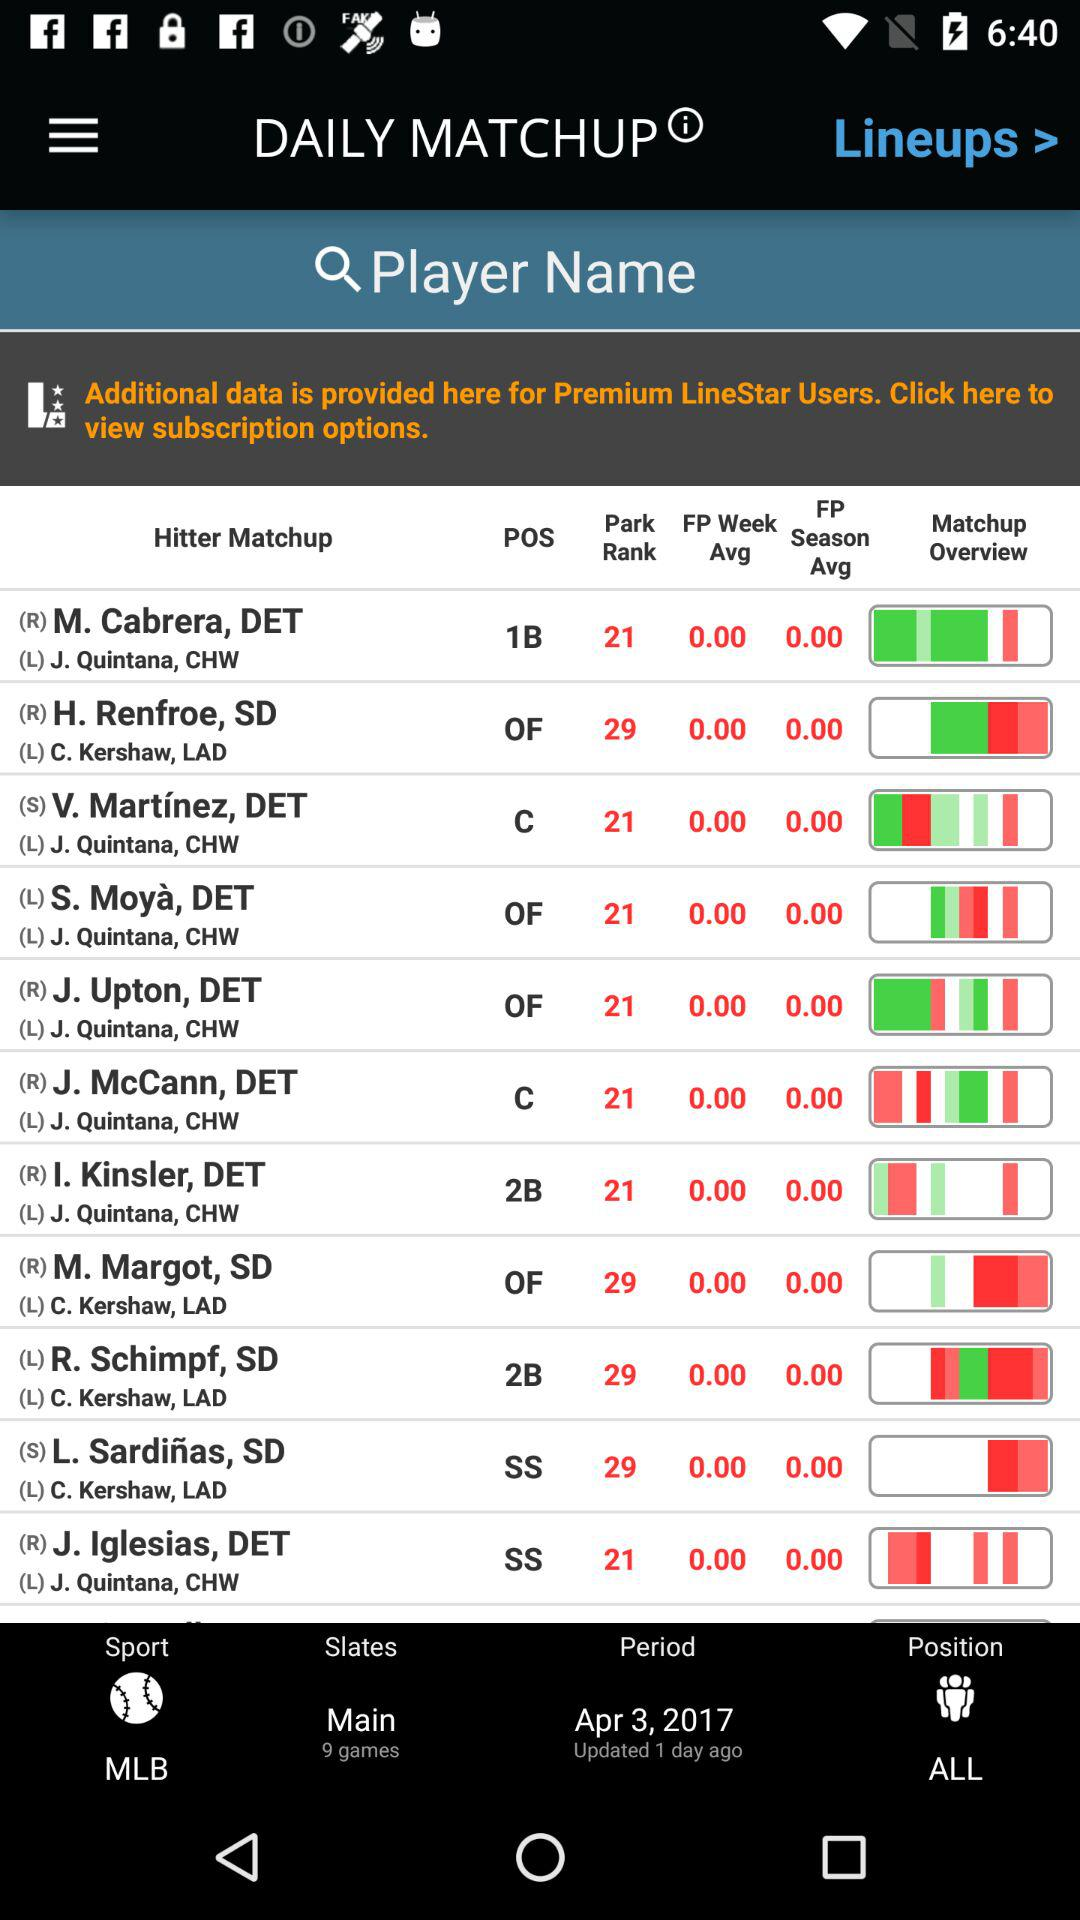How many games are in the "Main" slates? There are 9 games. 